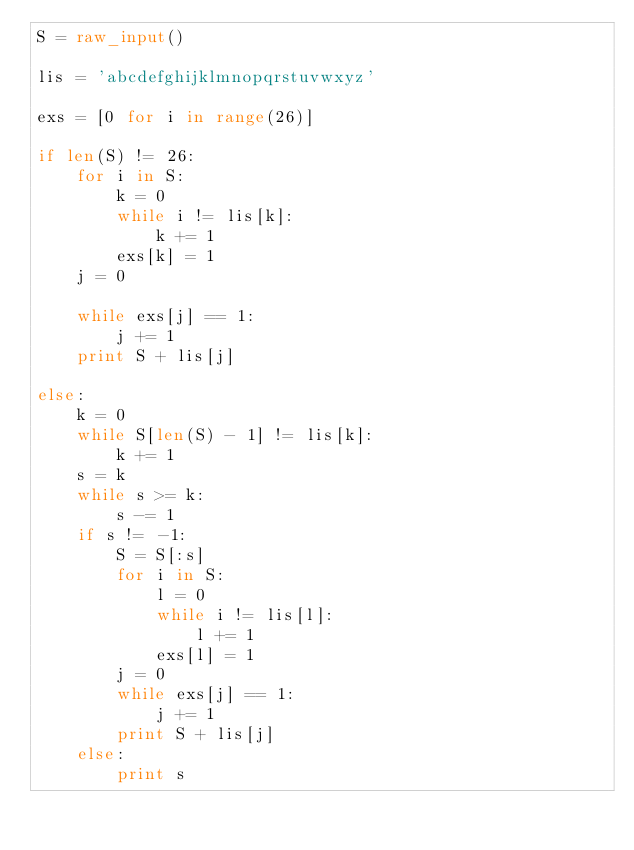<code> <loc_0><loc_0><loc_500><loc_500><_Python_>S = raw_input()

lis = 'abcdefghijklmnopqrstuvwxyz'

exs = [0 for i in range(26)]

if len(S) != 26:
    for i in S:
        k = 0
        while i != lis[k]:
            k += 1
        exs[k] = 1
    j = 0
    
    while exs[j] == 1:
        j += 1
    print S + lis[j]

else:
    k = 0
    while S[len(S) - 1] != lis[k]:
        k += 1
    s = k
    while s >= k:
        s -= 1
    if s != -1:
        S = S[:s]
        for i in S:
            l = 0
            while i != lis[l]:
                l += 1
            exs[l] = 1
        j = 0
        while exs[j] == 1:
            j += 1
        print S + lis[j]
    else:
        print s</code> 